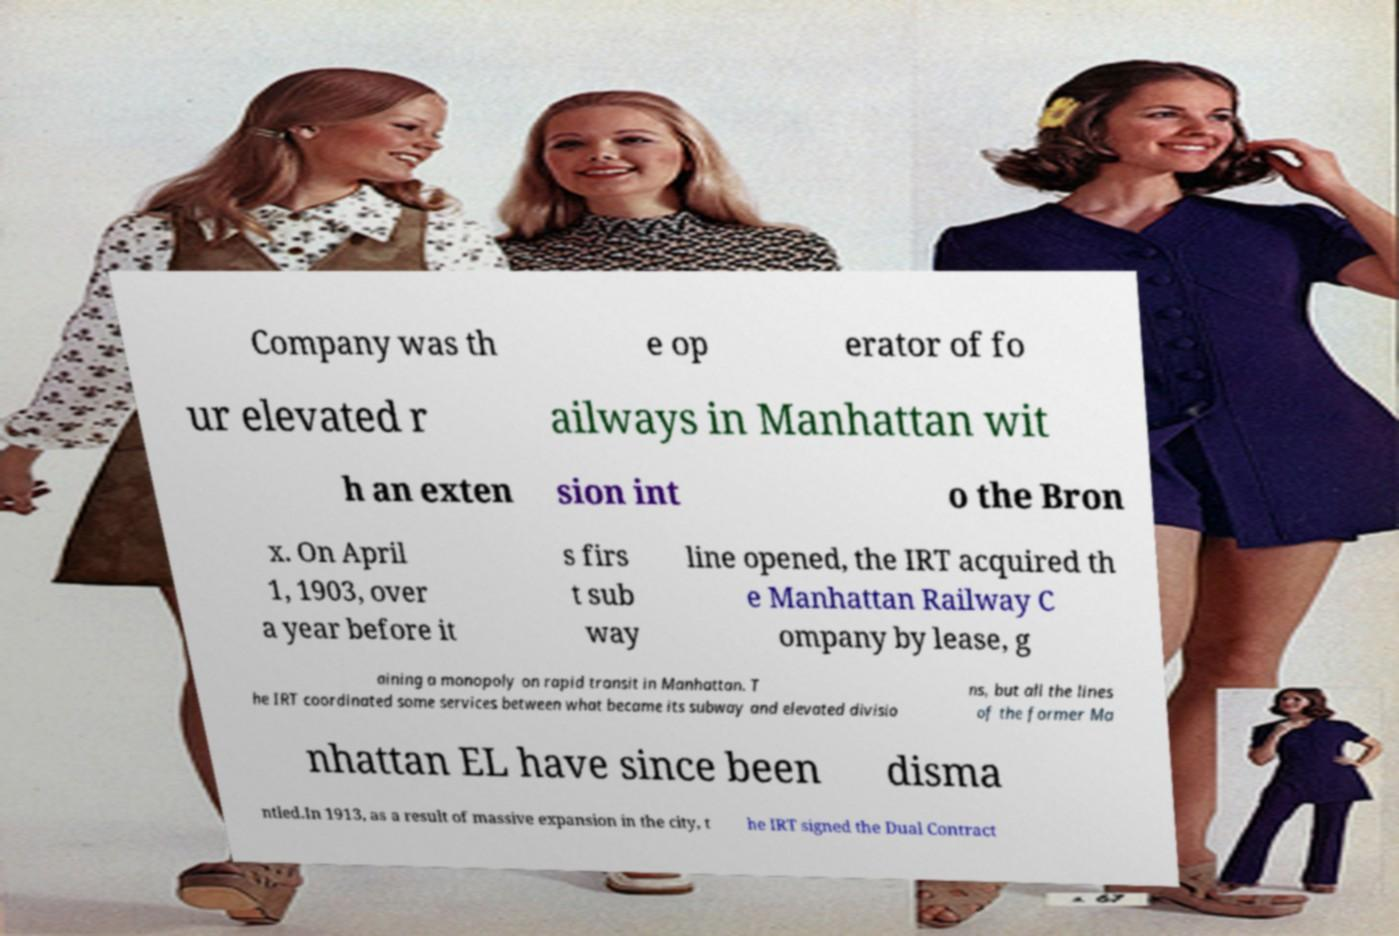What messages or text are displayed in this image? I need them in a readable, typed format. Company was th e op erator of fo ur elevated r ailways in Manhattan wit h an exten sion int o the Bron x. On April 1, 1903, over a year before it s firs t sub way line opened, the IRT acquired th e Manhattan Railway C ompany by lease, g aining a monopoly on rapid transit in Manhattan. T he IRT coordinated some services between what became its subway and elevated divisio ns, but all the lines of the former Ma nhattan EL have since been disma ntled.In 1913, as a result of massive expansion in the city, t he IRT signed the Dual Contract 